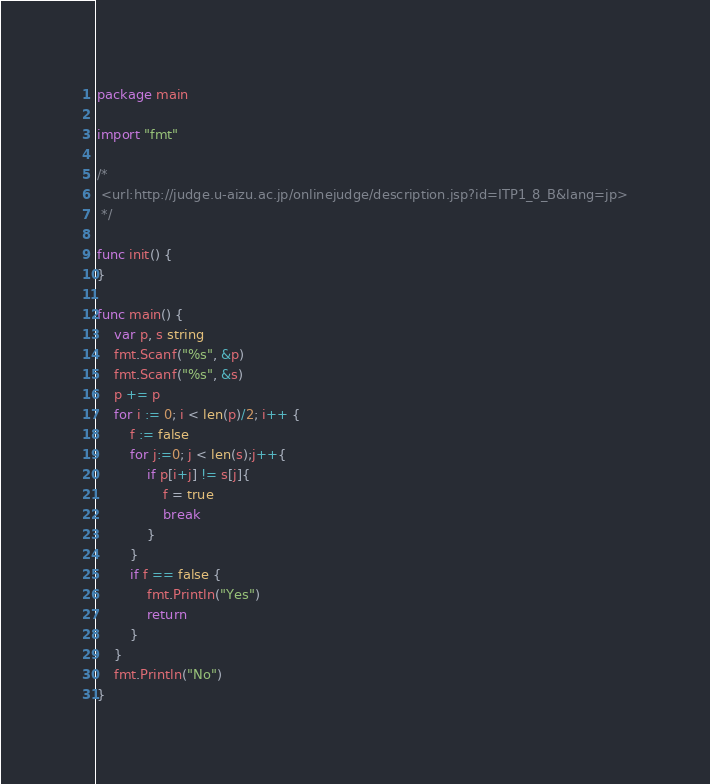<code> <loc_0><loc_0><loc_500><loc_500><_Go_>package main

import "fmt"

/*
 <url:http://judge.u-aizu.ac.jp/onlinejudge/description.jsp?id=ITP1_8_B&lang=jp>
 */

func init() {
}

func main() {
	var p, s string
	fmt.Scanf("%s", &p)
	fmt.Scanf("%s", &s)
	p += p
	for i := 0; i < len(p)/2; i++ {
		f := false
		for j:=0; j < len(s);j++{
			if p[i+j] != s[j]{
				f = true
				break
			}
		}
		if f == false {
			fmt.Println("Yes")
			return
		}
	}
	fmt.Println("No")
}</code> 